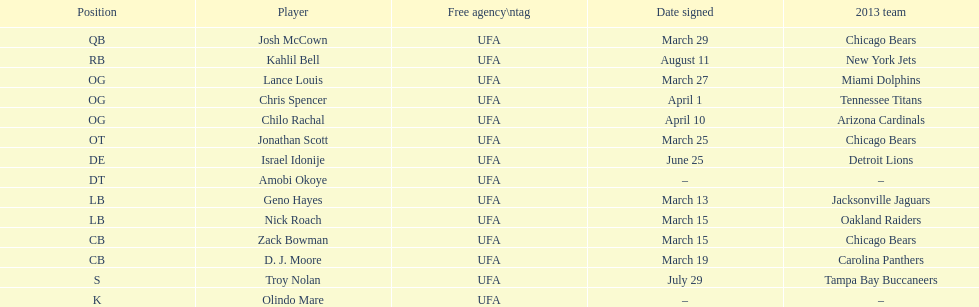According to this chart, which position is played the most? OG. 